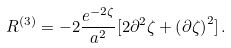<formula> <loc_0><loc_0><loc_500><loc_500>R ^ { ( 3 ) } = - 2 \frac { e ^ { - 2 \zeta } } { a ^ { 2 } } [ 2 \partial ^ { 2 } \zeta + \left ( \partial \zeta \right ) ^ { 2 } ] \, .</formula> 